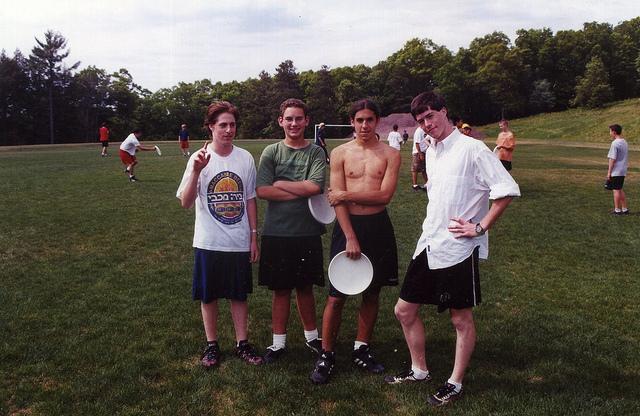What color shirts are these people wearing?
Give a very brief answer. White and green. How many people are wearing red?
Answer briefly. 3. What is the shirtless man holding?
Concise answer only. Frisbee. How many guys that are shirtless?
Keep it brief. 1. Are these people all wearing the same color shirt?
Answer briefly. No. 